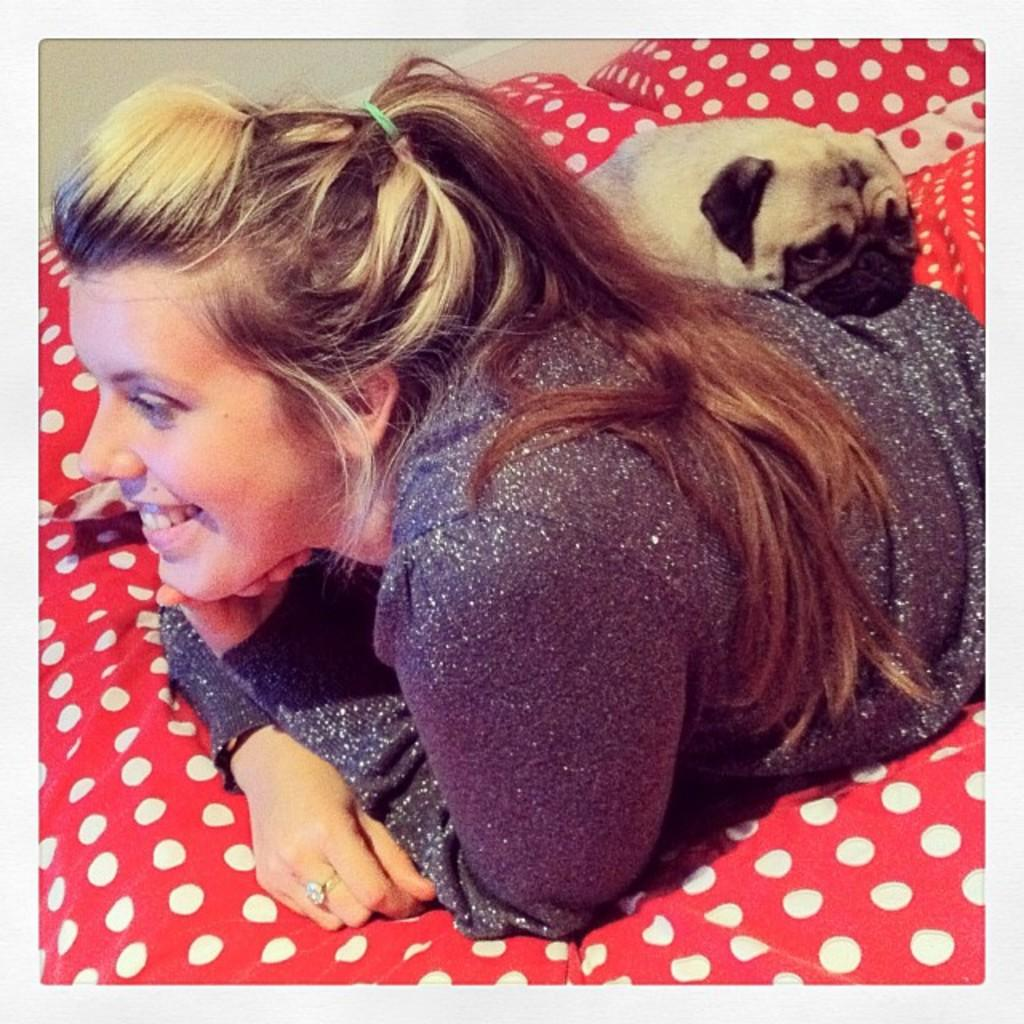Who is present in the image? There is a woman in the image. What is the woman doing in the image? The woman is laying on a bed. What is the woman's facial expression in the image? The woman is smiling. Are there any animals present in the image? Yes, there is a dog in the image. Where is the dog located in relation to the woman? The dog is behind the woman. What type of slave is depicted in the image? There is no slave present in the image; it features a woman laying on a bed and a dog behind her. Can you tell me where the zoo is located in the image? There is no zoo present in the image. 